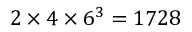Convert formula to latex. <formula><loc_0><loc_0><loc_500><loc_500>2 \times 4 \times 6 ^ { 3 } = 1 7 2 8</formula> 